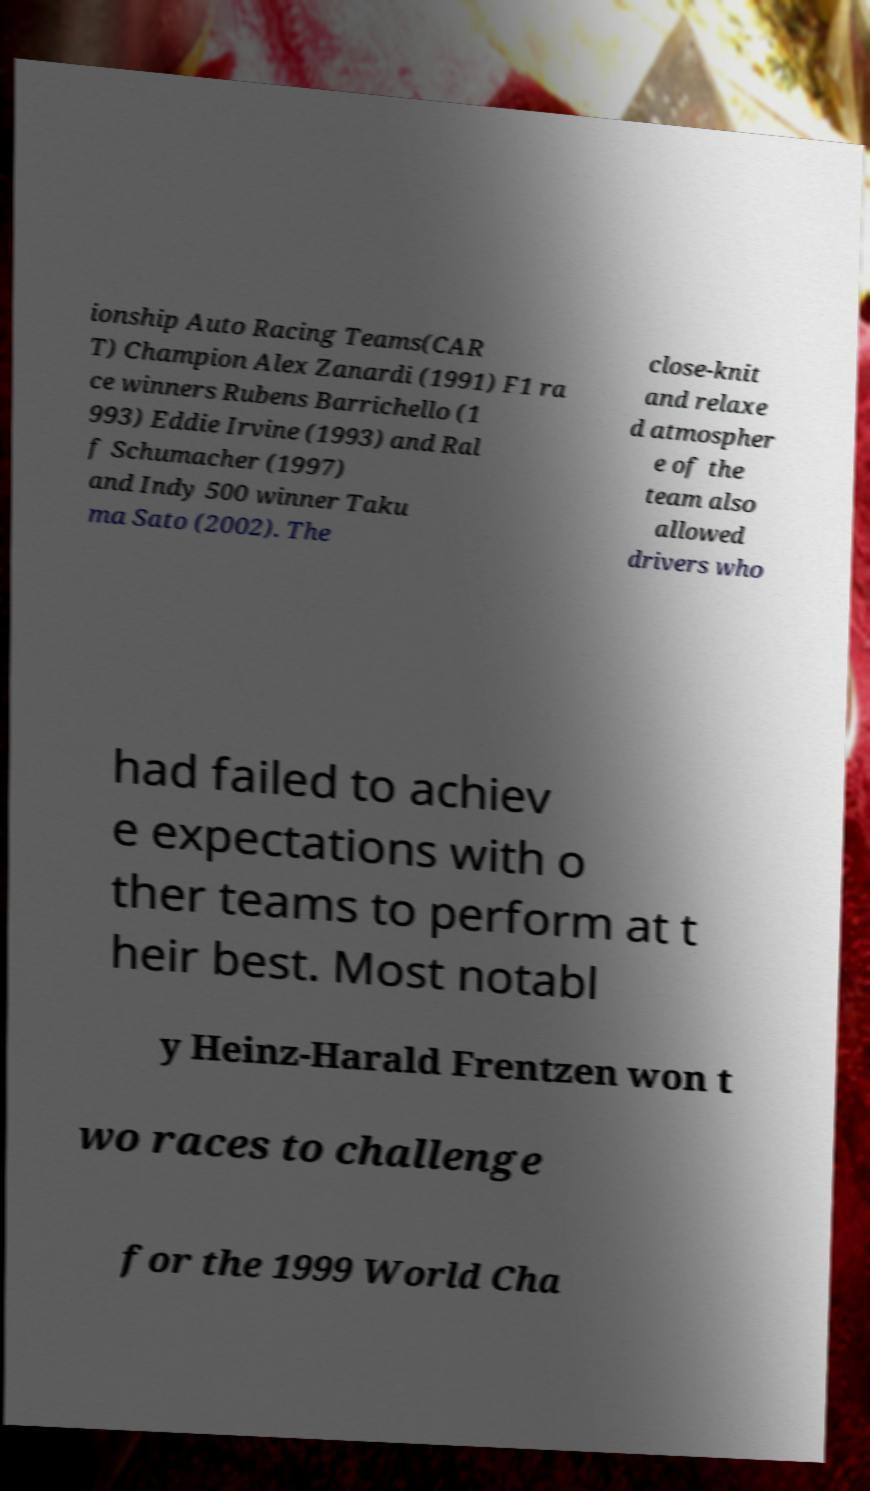There's text embedded in this image that I need extracted. Can you transcribe it verbatim? ionship Auto Racing Teams(CAR T) Champion Alex Zanardi (1991) F1 ra ce winners Rubens Barrichello (1 993) Eddie Irvine (1993) and Ral f Schumacher (1997) and Indy 500 winner Taku ma Sato (2002). The close-knit and relaxe d atmospher e of the team also allowed drivers who had failed to achiev e expectations with o ther teams to perform at t heir best. Most notabl y Heinz-Harald Frentzen won t wo races to challenge for the 1999 World Cha 